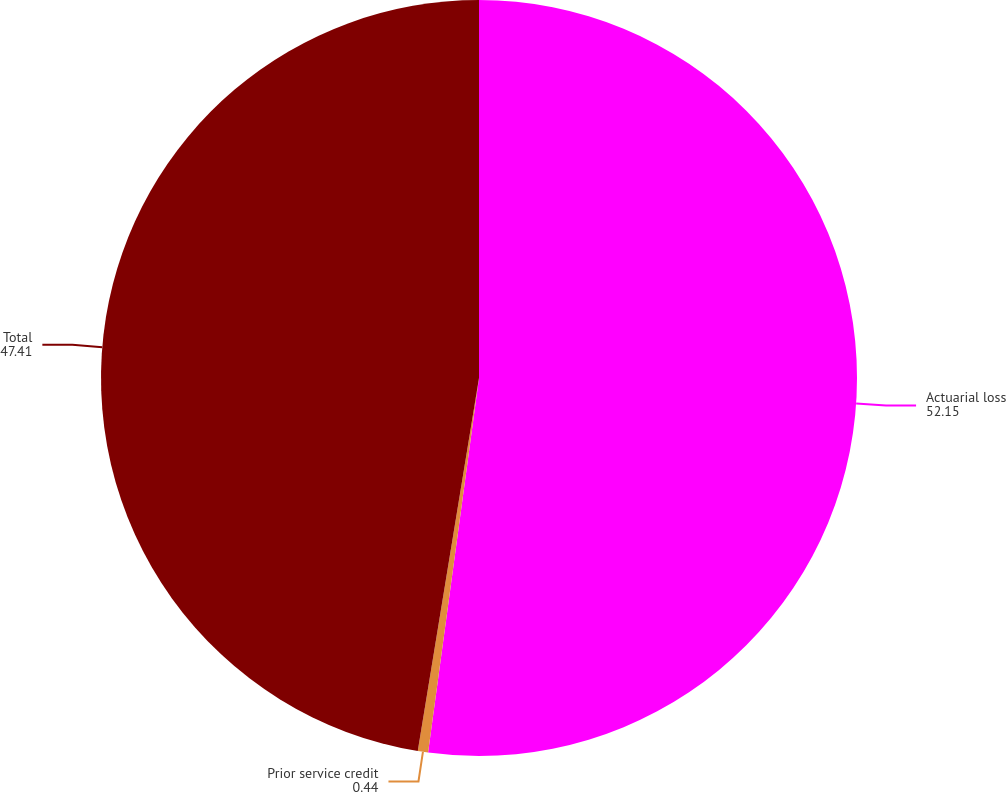Convert chart. <chart><loc_0><loc_0><loc_500><loc_500><pie_chart><fcel>Actuarial loss<fcel>Prior service credit<fcel>Total<nl><fcel>52.15%<fcel>0.44%<fcel>47.41%<nl></chart> 